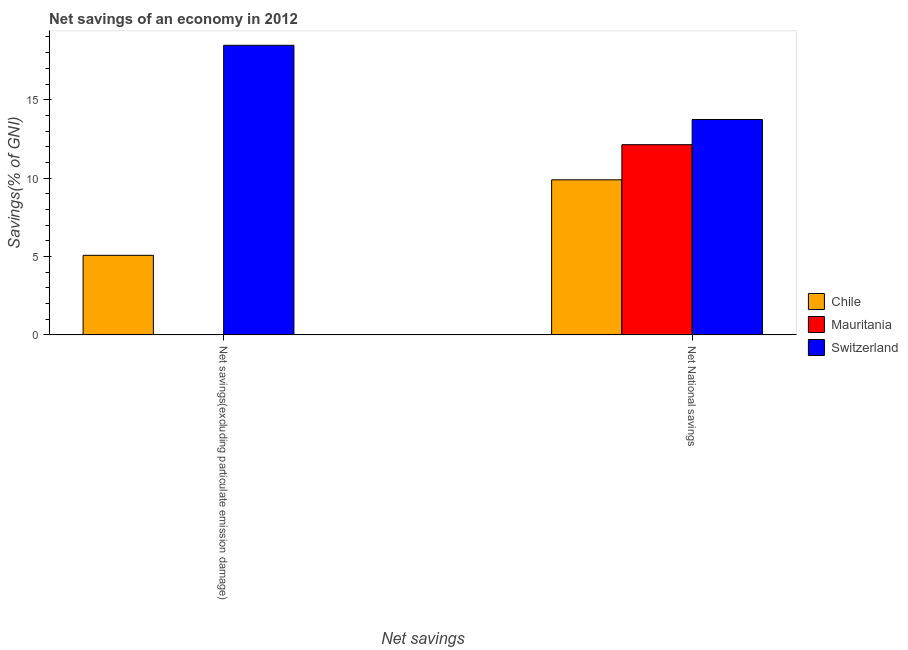How many different coloured bars are there?
Provide a succinct answer. 3. Are the number of bars per tick equal to the number of legend labels?
Ensure brevity in your answer.  No. Are the number of bars on each tick of the X-axis equal?
Offer a very short reply. No. What is the label of the 2nd group of bars from the left?
Your answer should be very brief. Net National savings. What is the net savings(excluding particulate emission damage) in Mauritania?
Give a very brief answer. 0. Across all countries, what is the maximum net national savings?
Give a very brief answer. 13.74. In which country was the net savings(excluding particulate emission damage) maximum?
Offer a terse response. Switzerland. What is the total net savings(excluding particulate emission damage) in the graph?
Offer a very short reply. 23.54. What is the difference between the net savings(excluding particulate emission damage) in Chile and that in Switzerland?
Keep it short and to the point. -13.39. What is the difference between the net national savings in Chile and the net savings(excluding particulate emission damage) in Mauritania?
Your answer should be compact. 9.89. What is the average net national savings per country?
Provide a succinct answer. 11.92. What is the difference between the net national savings and net savings(excluding particulate emission damage) in Switzerland?
Provide a short and direct response. -4.73. In how many countries, is the net national savings greater than 1 %?
Your response must be concise. 3. What is the ratio of the net national savings in Chile to that in Mauritania?
Make the answer very short. 0.82. Is the net national savings in Chile less than that in Switzerland?
Keep it short and to the point. Yes. In how many countries, is the net savings(excluding particulate emission damage) greater than the average net savings(excluding particulate emission damage) taken over all countries?
Provide a short and direct response. 1. How many bars are there?
Make the answer very short. 5. Are all the bars in the graph horizontal?
Give a very brief answer. No. How many countries are there in the graph?
Offer a terse response. 3. What is the difference between two consecutive major ticks on the Y-axis?
Your answer should be very brief. 5. Where does the legend appear in the graph?
Provide a succinct answer. Center right. What is the title of the graph?
Offer a terse response. Net savings of an economy in 2012. Does "China" appear as one of the legend labels in the graph?
Offer a terse response. No. What is the label or title of the X-axis?
Ensure brevity in your answer.  Net savings. What is the label or title of the Y-axis?
Your answer should be very brief. Savings(% of GNI). What is the Savings(% of GNI) in Chile in Net savings(excluding particulate emission damage)?
Give a very brief answer. 5.08. What is the Savings(% of GNI) in Switzerland in Net savings(excluding particulate emission damage)?
Provide a succinct answer. 18.47. What is the Savings(% of GNI) in Chile in Net National savings?
Provide a succinct answer. 9.89. What is the Savings(% of GNI) of Mauritania in Net National savings?
Offer a very short reply. 12.13. What is the Savings(% of GNI) in Switzerland in Net National savings?
Provide a short and direct response. 13.74. Across all Net savings, what is the maximum Savings(% of GNI) in Chile?
Your response must be concise. 9.89. Across all Net savings, what is the maximum Savings(% of GNI) in Mauritania?
Provide a short and direct response. 12.13. Across all Net savings, what is the maximum Savings(% of GNI) of Switzerland?
Your answer should be very brief. 18.47. Across all Net savings, what is the minimum Savings(% of GNI) in Chile?
Your answer should be very brief. 5.08. Across all Net savings, what is the minimum Savings(% of GNI) of Switzerland?
Ensure brevity in your answer.  13.74. What is the total Savings(% of GNI) in Chile in the graph?
Keep it short and to the point. 14.97. What is the total Savings(% of GNI) of Mauritania in the graph?
Give a very brief answer. 12.13. What is the total Savings(% of GNI) of Switzerland in the graph?
Your answer should be very brief. 32.21. What is the difference between the Savings(% of GNI) of Chile in Net savings(excluding particulate emission damage) and that in Net National savings?
Give a very brief answer. -4.81. What is the difference between the Savings(% of GNI) in Switzerland in Net savings(excluding particulate emission damage) and that in Net National savings?
Make the answer very short. 4.73. What is the difference between the Savings(% of GNI) of Chile in Net savings(excluding particulate emission damage) and the Savings(% of GNI) of Mauritania in Net National savings?
Give a very brief answer. -7.06. What is the difference between the Savings(% of GNI) in Chile in Net savings(excluding particulate emission damage) and the Savings(% of GNI) in Switzerland in Net National savings?
Offer a very short reply. -8.66. What is the average Savings(% of GNI) of Chile per Net savings?
Offer a terse response. 7.48. What is the average Savings(% of GNI) in Mauritania per Net savings?
Make the answer very short. 6.07. What is the average Savings(% of GNI) in Switzerland per Net savings?
Your response must be concise. 16.1. What is the difference between the Savings(% of GNI) in Chile and Savings(% of GNI) in Switzerland in Net savings(excluding particulate emission damage)?
Provide a short and direct response. -13.39. What is the difference between the Savings(% of GNI) of Chile and Savings(% of GNI) of Mauritania in Net National savings?
Make the answer very short. -2.24. What is the difference between the Savings(% of GNI) of Chile and Savings(% of GNI) of Switzerland in Net National savings?
Provide a short and direct response. -3.85. What is the difference between the Savings(% of GNI) in Mauritania and Savings(% of GNI) in Switzerland in Net National savings?
Ensure brevity in your answer.  -1.61. What is the ratio of the Savings(% of GNI) of Chile in Net savings(excluding particulate emission damage) to that in Net National savings?
Offer a terse response. 0.51. What is the ratio of the Savings(% of GNI) of Switzerland in Net savings(excluding particulate emission damage) to that in Net National savings?
Your answer should be very brief. 1.34. What is the difference between the highest and the second highest Savings(% of GNI) in Chile?
Provide a succinct answer. 4.81. What is the difference between the highest and the second highest Savings(% of GNI) of Switzerland?
Offer a very short reply. 4.73. What is the difference between the highest and the lowest Savings(% of GNI) of Chile?
Offer a terse response. 4.81. What is the difference between the highest and the lowest Savings(% of GNI) in Mauritania?
Offer a terse response. 12.13. What is the difference between the highest and the lowest Savings(% of GNI) in Switzerland?
Provide a short and direct response. 4.73. 